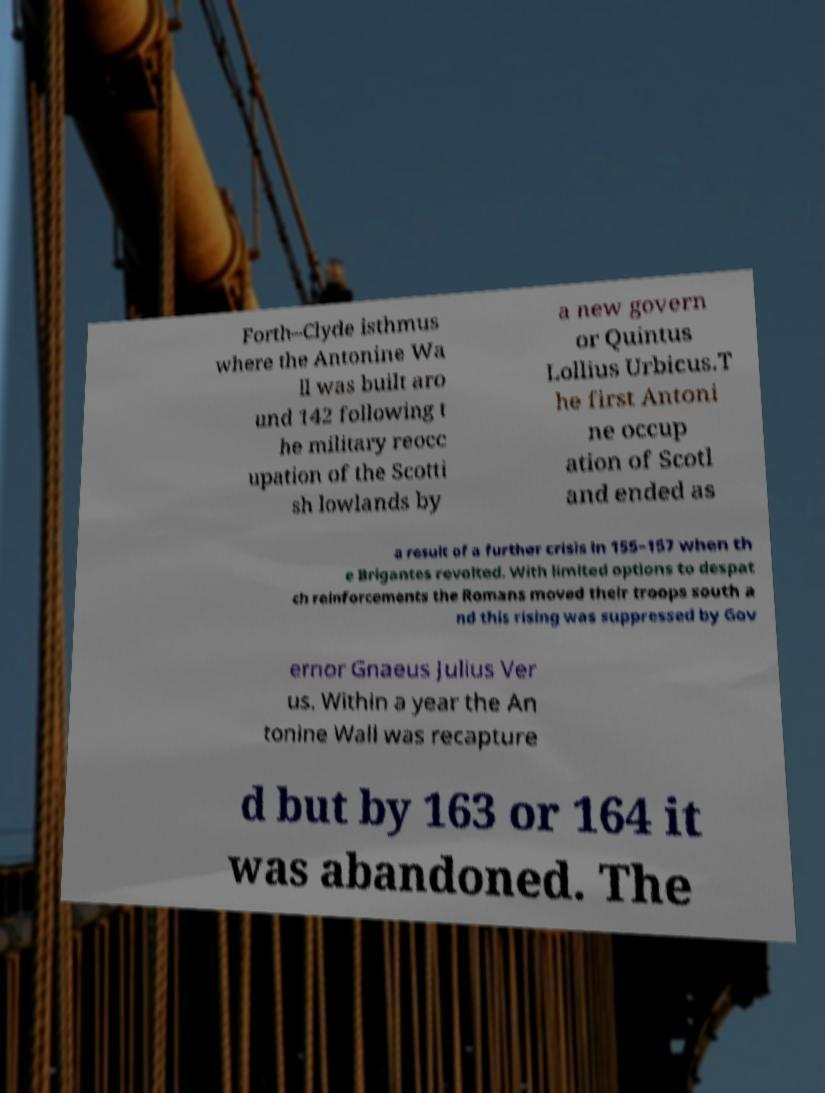For documentation purposes, I need the text within this image transcribed. Could you provide that? Forth–Clyde isthmus where the Antonine Wa ll was built aro und 142 following t he military reocc upation of the Scotti sh lowlands by a new govern or Quintus Lollius Urbicus.T he first Antoni ne occup ation of Scotl and ended as a result of a further crisis in 155–157 when th e Brigantes revolted. With limited options to despat ch reinforcements the Romans moved their troops south a nd this rising was suppressed by Gov ernor Gnaeus Julius Ver us. Within a year the An tonine Wall was recapture d but by 163 or 164 it was abandoned. The 